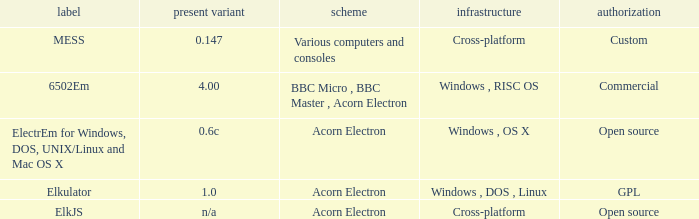What is the system called that is named ELKJS? Acorn Electron. 